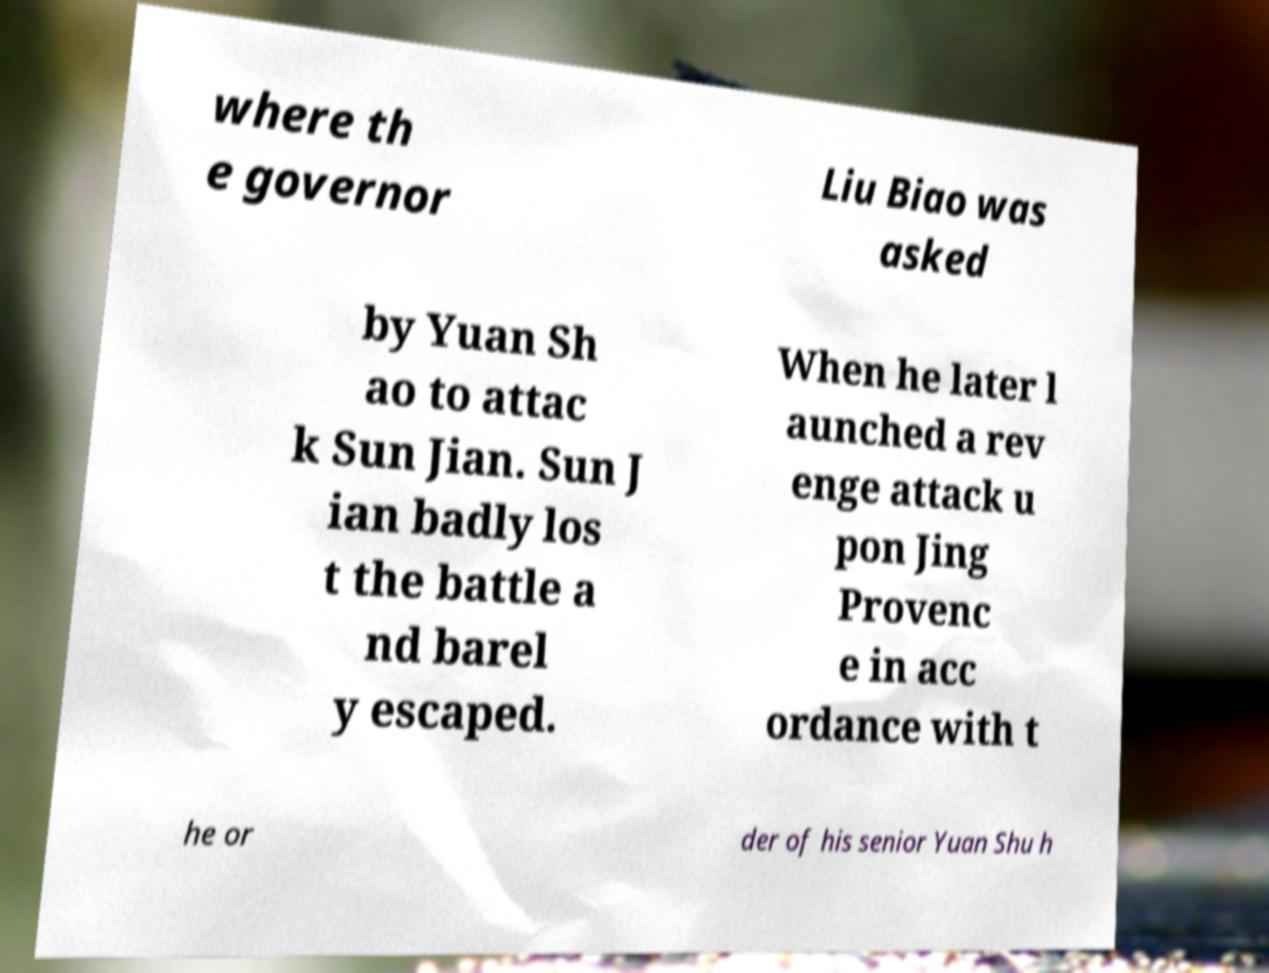Please read and relay the text visible in this image. What does it say? where th e governor Liu Biao was asked by Yuan Sh ao to attac k Sun Jian. Sun J ian badly los t the battle a nd barel y escaped. When he later l aunched a rev enge attack u pon Jing Provenc e in acc ordance with t he or der of his senior Yuan Shu h 